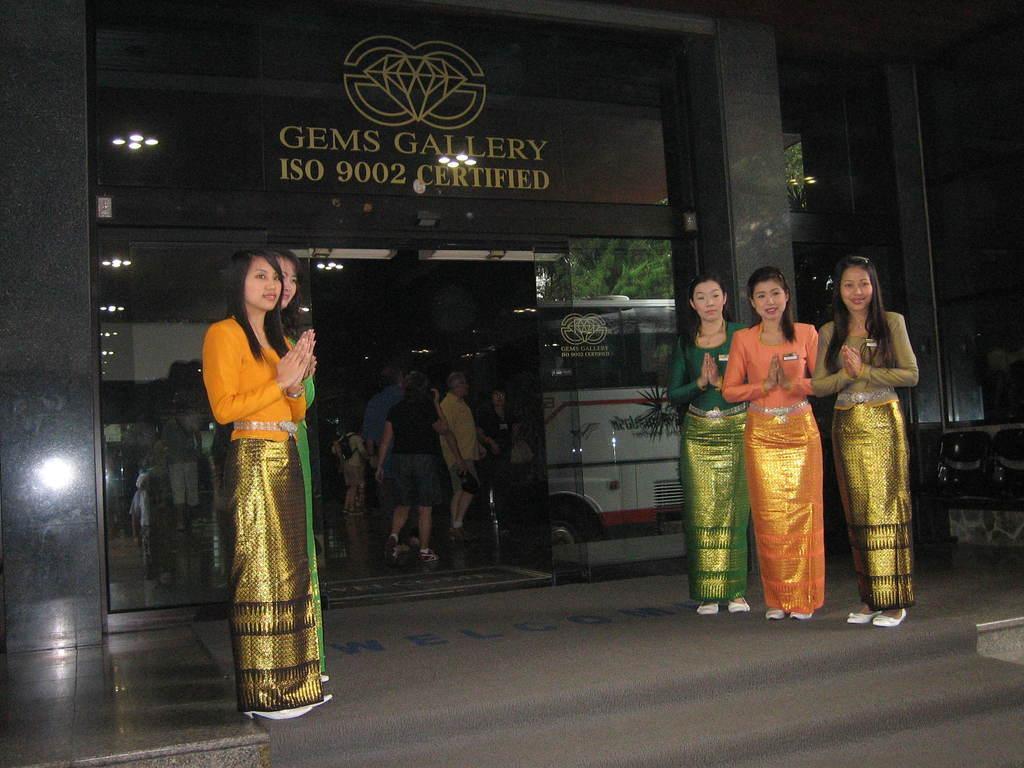Please provide a concise description of this image. In this image, we can see some women standing, there are some people walking into the building, we can see the reflection of a bus on the mirror. 